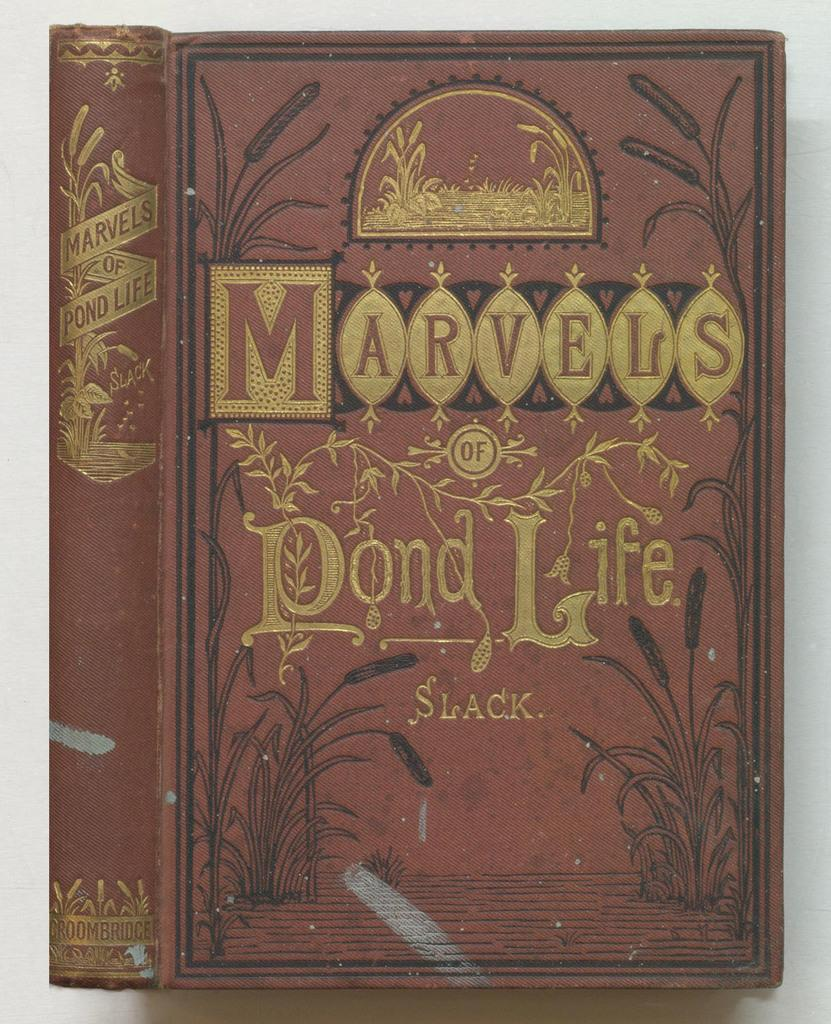What object can be seen in the image? There is a book in the image. What is the color of the book? The book is brown in color. What is the title of the book? The title of the book is "marvels of pond life". How does the book increase the size of the pond in the image? The book does not increase the size of the pond in the image; it is a book about pond life, not a tool for altering the pond's dimensions. 